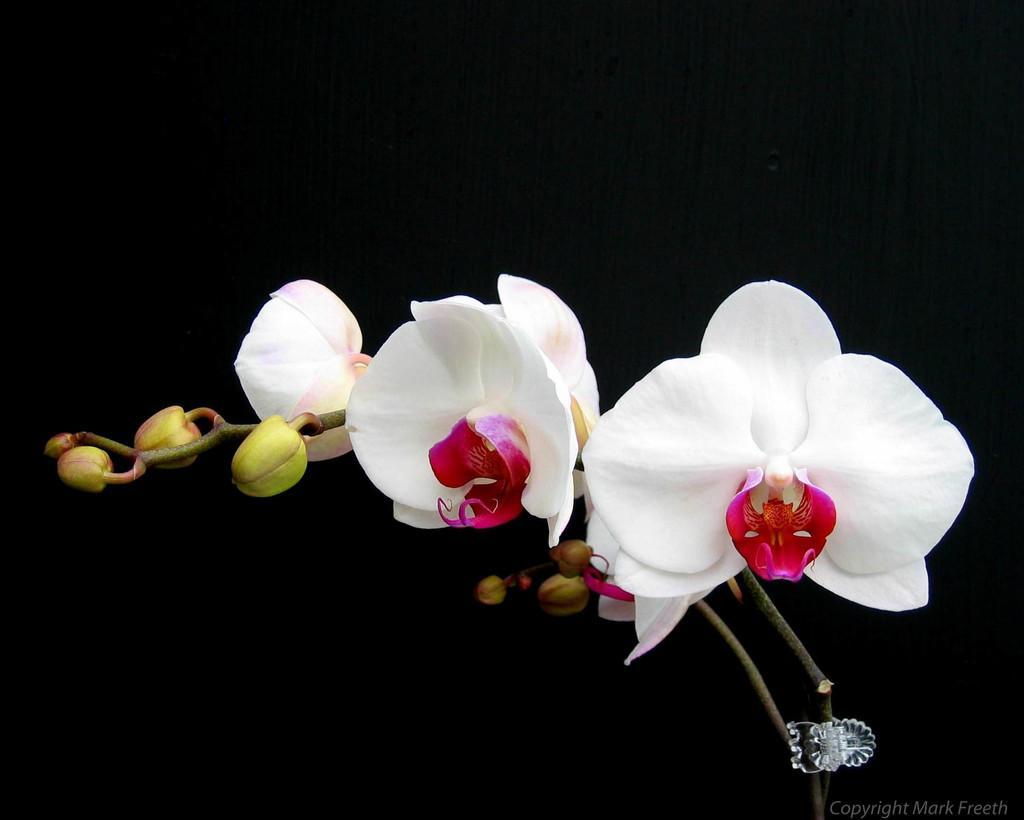Please provide a concise description of this image. In this image we can see few flowers and buds and a dark background. 